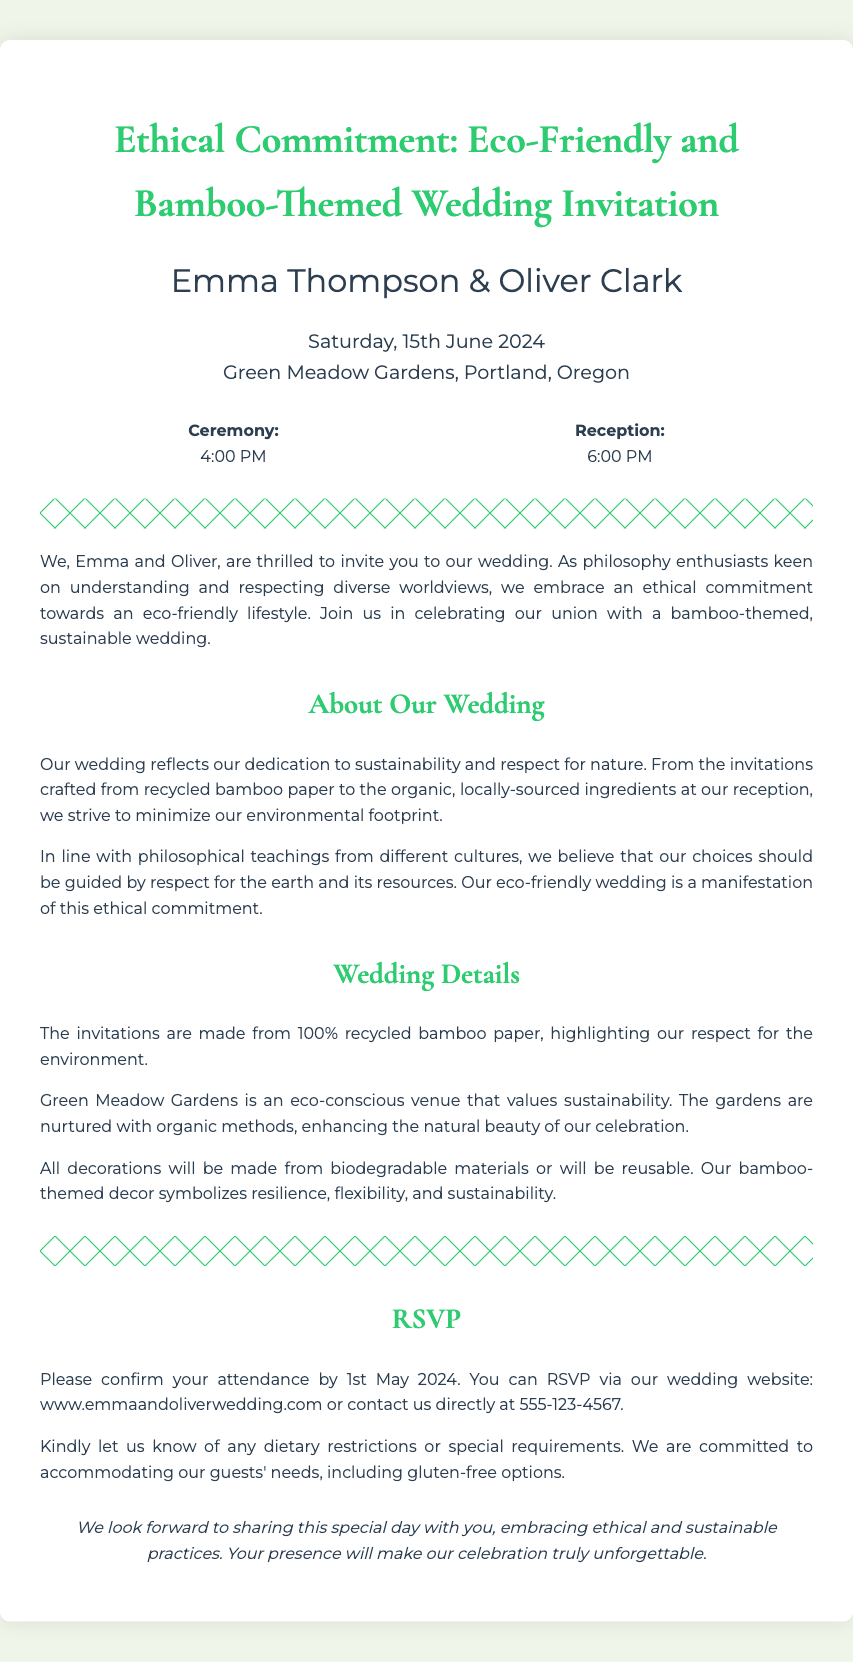What are the names of the couple? The document explicitly states the names of the couple in the title and introductory paragraph.
Answer: Emma Thompson & Oliver Clark What is the wedding date? The wedding date is clearly provided in the date-location section.
Answer: Saturday, 15th June 2024 Where is the wedding venue located? The venue is mentioned in the date-location section.
Answer: Green Meadow Gardens, Portland, Oregon What time does the ceremony start? The ceremony time is listed in the time section.
Answer: 4:00 PM What material are the invitations made from? The document specifies the material used for the invitations in the details section.
Answer: 100% recycled bamboo paper What philosophical approach do Emma and Oliver embrace? The intro section discusses their ethical commitment to eco-friendliness.
Answer: Ethical commitment towards an eco-friendly lifestyle By when should guests RSVP? The RSVP deadline is noted in the RSVP section.
Answer: 1st May 2024 Why is bamboo-themed decor chosen for the wedding? The details section explains the symbolism behind the bamboo theme.
Answer: Symbolizes resilience, flexibility, and sustainability What type of venue is Green Meadow Gardens? This is explained in the details section about the venue's characteristics.
Answer: Eco-conscious venue that values sustainability 